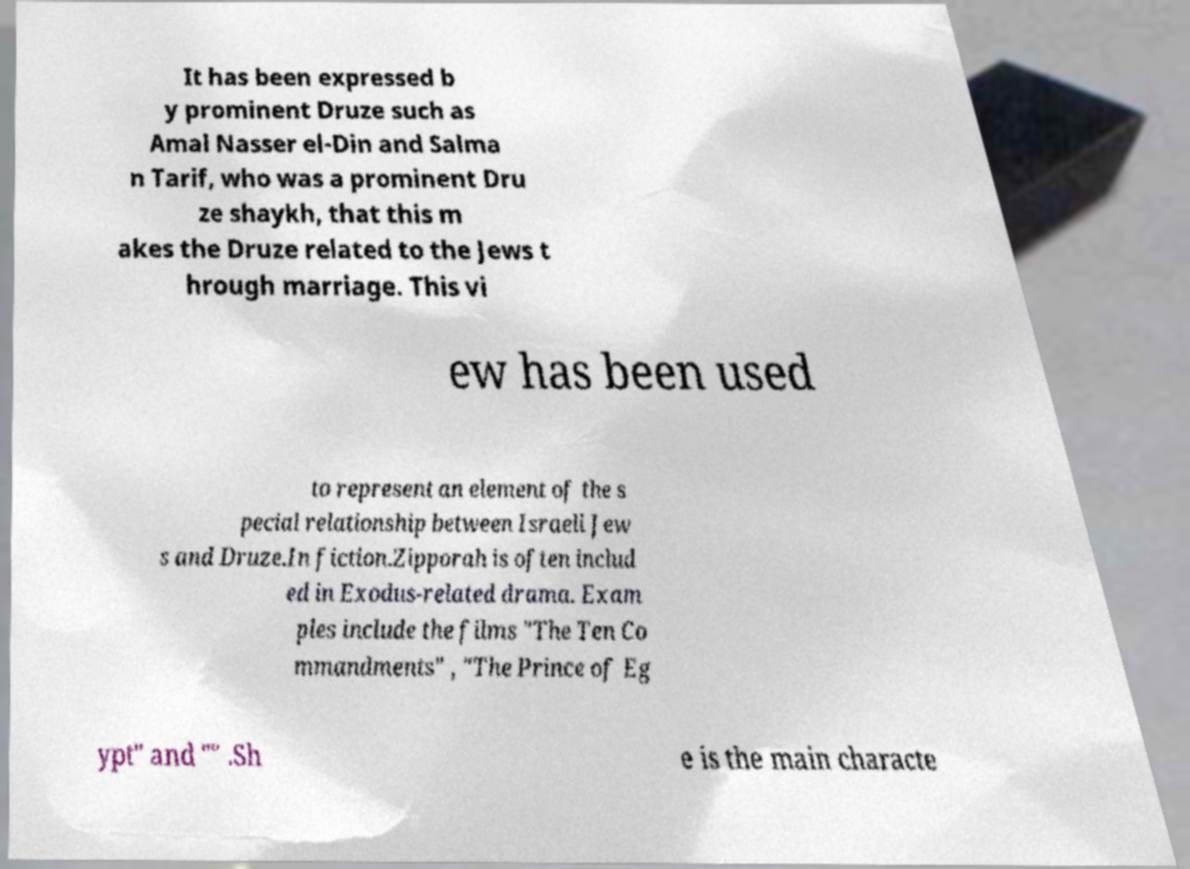For documentation purposes, I need the text within this image transcribed. Could you provide that? It has been expressed b y prominent Druze such as Amal Nasser el-Din and Salma n Tarif, who was a prominent Dru ze shaykh, that this m akes the Druze related to the Jews t hrough marriage. This vi ew has been used to represent an element of the s pecial relationship between Israeli Jew s and Druze.In fiction.Zipporah is often includ ed in Exodus-related drama. Exam ples include the films "The Ten Co mmandments" , "The Prince of Eg ypt" and "" .Sh e is the main characte 